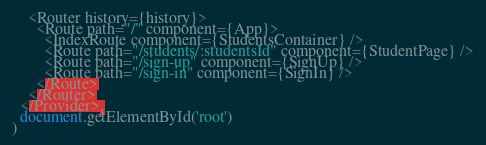Convert code to text. <code><loc_0><loc_0><loc_500><loc_500><_JavaScript_>    <Router history={history}>
      <Route path="/" component={App}>
        <IndexRoute component={StudentsContainer} />
        <Route path="/students/:studentsId" component={StudentPage} />
        <Route path="/sign-up" component={SignUp} />
        <Route path="/sign-in" component={SignIn} />
      </Route>
    </Router>
  </Provider>,
  document.getElementById('root')
)
</code> 